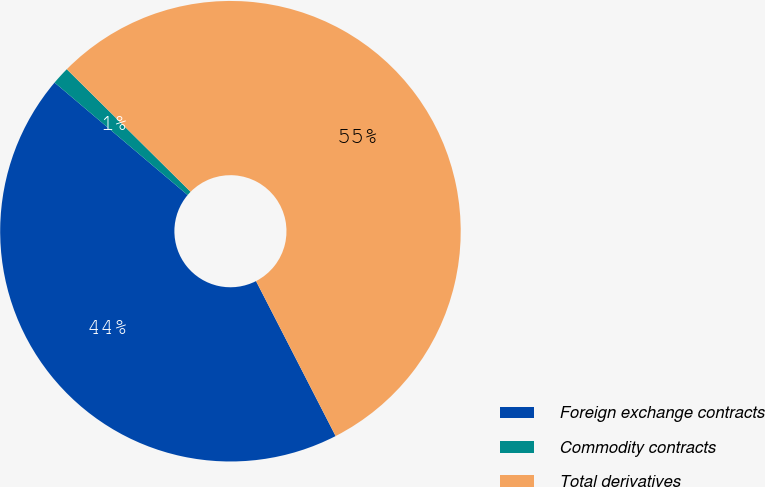Convert chart to OTSL. <chart><loc_0><loc_0><loc_500><loc_500><pie_chart><fcel>Foreign exchange contracts<fcel>Commodity contracts<fcel>Total derivatives<nl><fcel>43.72%<fcel>1.25%<fcel>55.03%<nl></chart> 